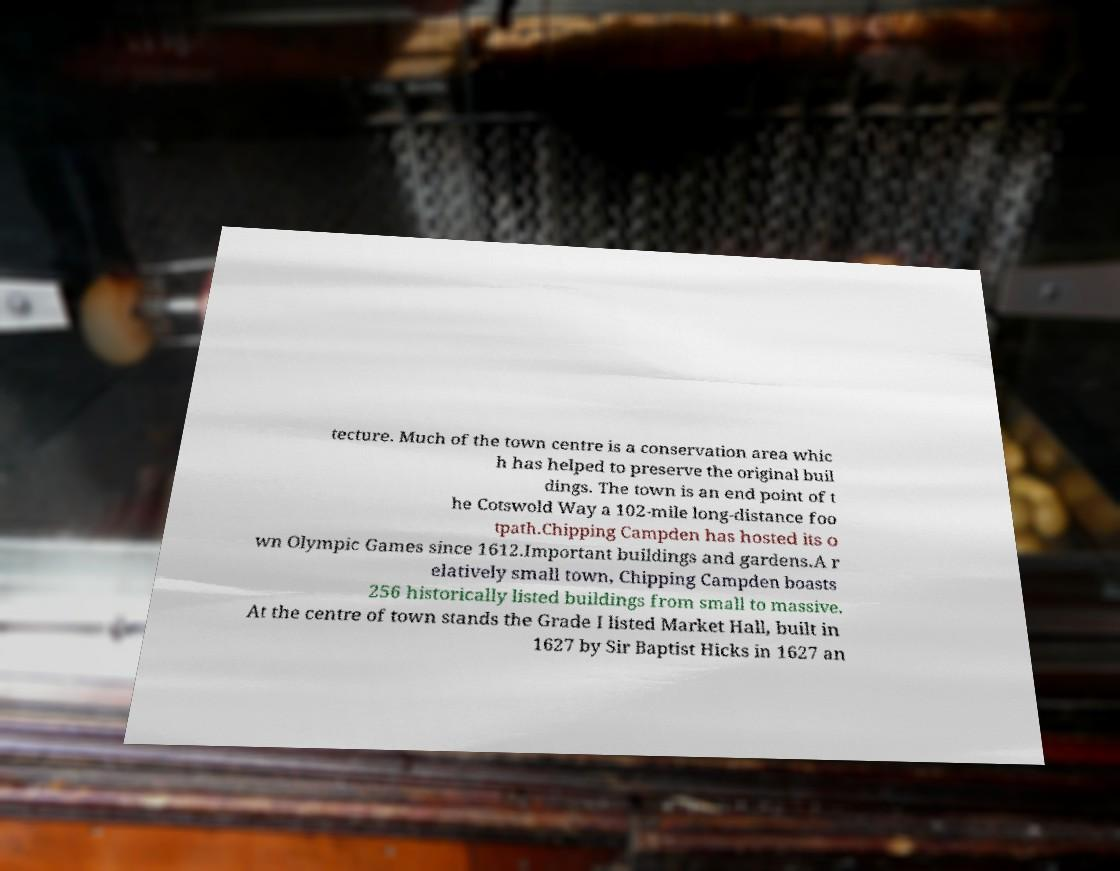Could you assist in decoding the text presented in this image and type it out clearly? tecture. Much of the town centre is a conservation area whic h has helped to preserve the original buil dings. The town is an end point of t he Cotswold Way a 102-mile long-distance foo tpath.Chipping Campden has hosted its o wn Olympic Games since 1612.Important buildings and gardens.A r elatively small town, Chipping Campden boasts 256 historically listed buildings from small to massive. At the centre of town stands the Grade I listed Market Hall, built in 1627 by Sir Baptist Hicks in 1627 an 